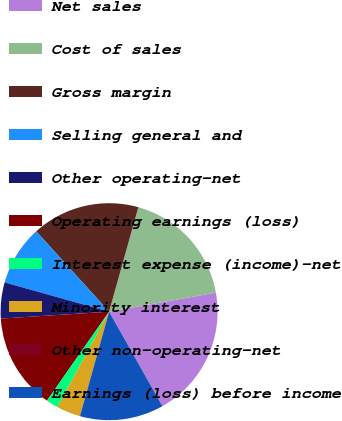Convert chart to OTSL. <chart><loc_0><loc_0><loc_500><loc_500><pie_chart><fcel>Net sales<fcel>Cost of sales<fcel>Gross margin<fcel>Selling general and<fcel>Other operating-net<fcel>Operating earnings (loss)<fcel>Interest expense (income)-net<fcel>Minority interest<fcel>Other non-operating-net<fcel>Earnings (loss) before income<nl><fcel>19.63%<fcel>17.85%<fcel>16.07%<fcel>8.93%<fcel>5.36%<fcel>14.28%<fcel>1.79%<fcel>3.58%<fcel>0.01%<fcel>12.5%<nl></chart> 